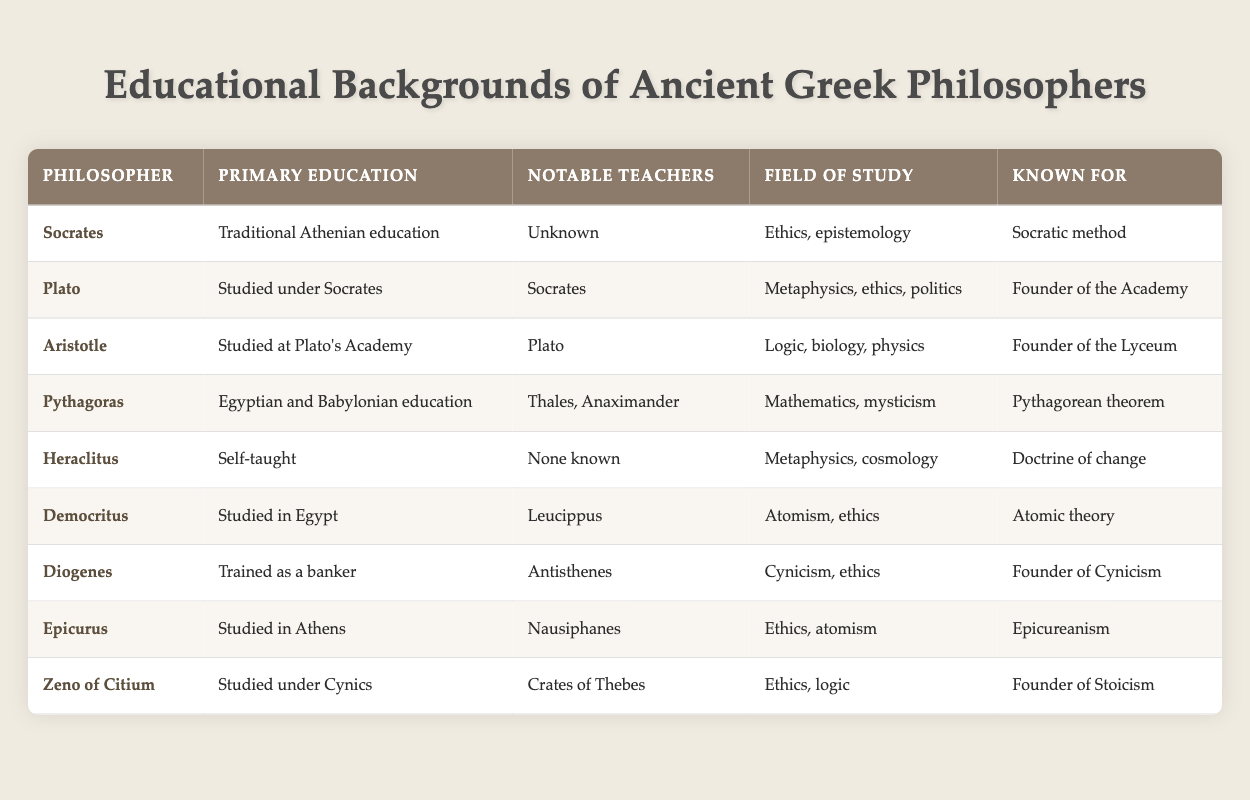What primary education did Aristotle receive? Aristotle studied at Plato's Academy, as indicated in the table under the "Primary Education" column.
Answer: Studied at Plato's Academy Who studied under Socrates? The table shows that Plato was a pupil of Socrates, as noted in the "Notable Teachers" column.
Answer: Plato Is it true that Diogenes was trained as a banker? The table explicitly states that Diogenes had training as a banker, making this a true statement based on the data.
Answer: Yes Which philosophers are known for their contributions to ethics? Socrates, Diogenes, Epicurus, and Zeno of Citium all have "ethics" listed under their "Field of Study" in the table.
Answer: Socrates, Diogenes, Epicurus, Zeno of Citium What is the average number of notable teachers for the philosophers listed? Counting the notable teachers, Socrates, Heraclitus, and Diogenes have no known notable teachers (3), while the rest have 1 each. So, with a total of 9 philosophers and a count of (3 + 1+1+1+1+1+1+1) = 9 notable teachers, the average is 9 / 9 = 1.
Answer: 1 How many philosophers studied in Egypt, and who were they? Looking at the table, Democritus is the only philosopher explicitly mentioned to have studied in Egypt, making the count one.
Answer: 1 philosopher: Democritus Which philosopher is associated with the Pythagorean theorem? From the "Known For" column, it is clear that Pythagoras is recognized for the Pythagorean theorem, as listed in the table.
Answer: Pythagoras List the three philosophers who are founders of their respective schools. The data presents three philosophers: Plato as the founder of the Academy, Aristotle as the founder of the Lyceum, and Zeno of Citium as the founder of Stoicism.
Answer: Plato, Aristotle, Zeno of Citium What is the relationship between Plato and Aristotle according to the table? According to the "Notable Teachers" column, Aristotle studied at Plato's Academy, indicating that Plato was a significant influence on Aristotle's education.
Answer: Teacher-Student relationship 